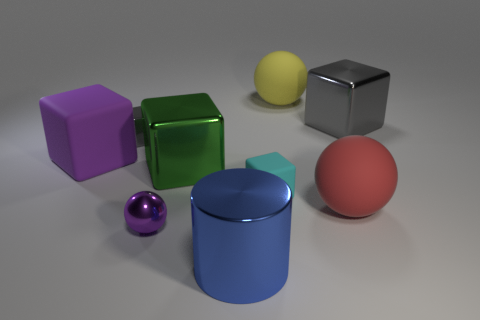How many objects in the image can roll? There are three objects in the image that can roll: the yellow sphere, the purple sphere, and the red sphere. Which of them would roll the fastest, assuming they were all pushed with the same force? Assuming they were all pushed with the same force, the smaller purple sphere would likely roll the fastest due to its smaller size and therefore lower moment of inertia, which generally means less resistance to changes in rotational speed. 